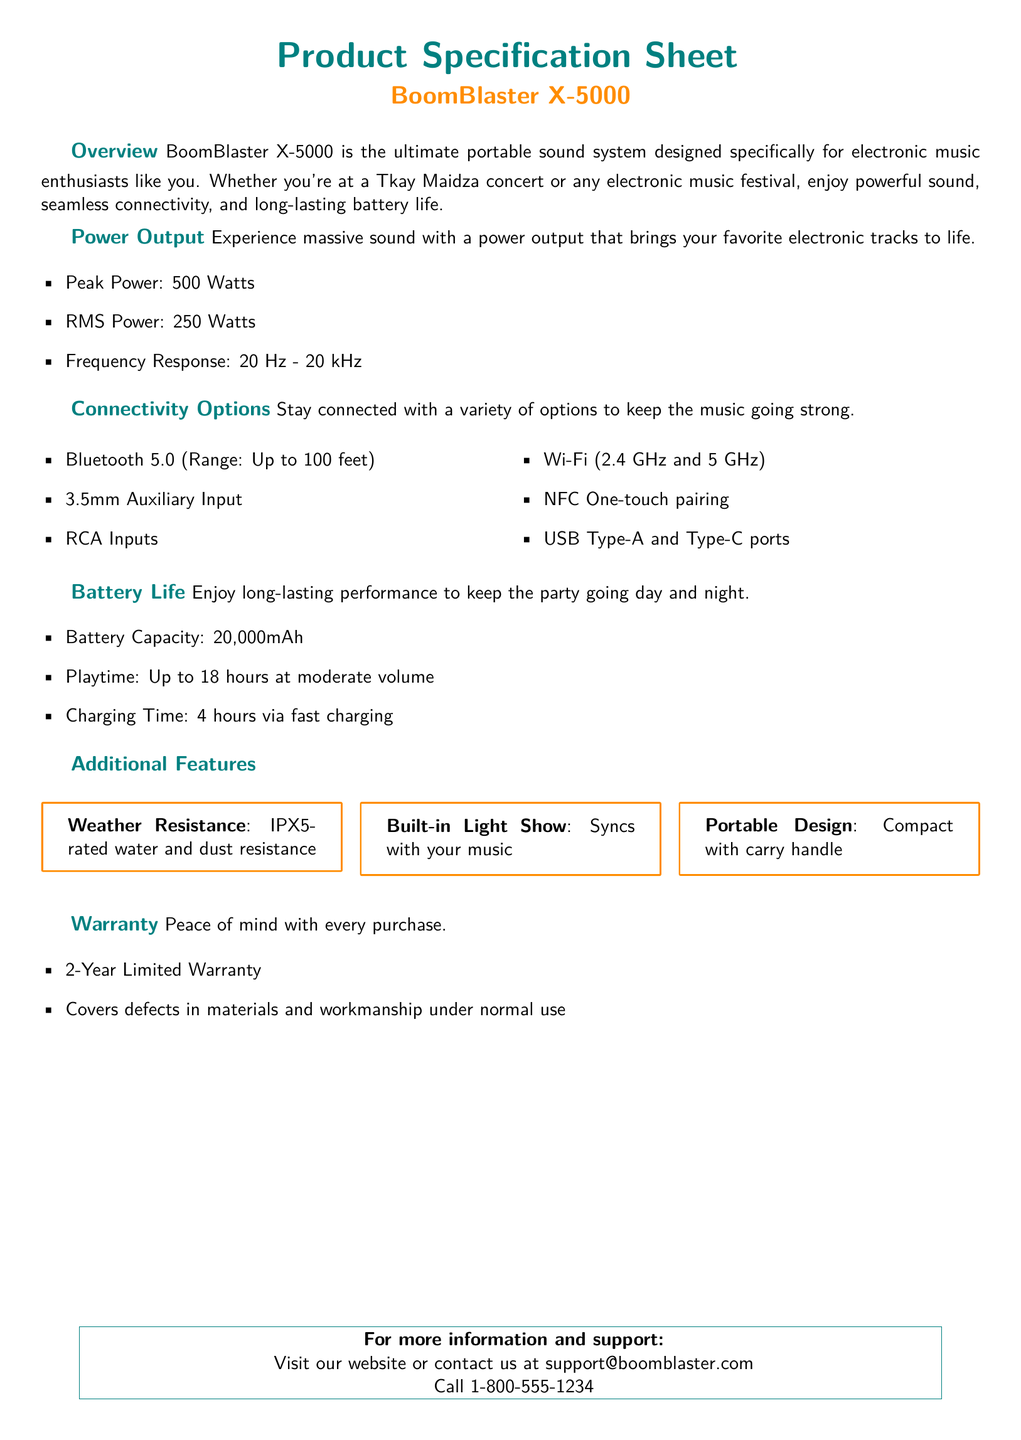What is the peak power output? The peak power output is specified in the document as 500 Watts.
Answer: 500 Watts What is the playtime at moderate volume? The document states that the playtime is up to 18 hours at moderate volume.
Answer: Up to 18 hours What connectivity option allows pairing with NFC? The document mentions NFC one-touch pairing as a connectivity option.
Answer: NFC One-touch pairing What is the battery capacity? The battery capacity listed in the document is 20,000mAh.
Answer: 20,000mAh What is the warranty period for the BoomBlaster X-5000? The document specifies a 2-Year Limited Warranty for the product.
Answer: 2-Year Limited Warranty How does the built-in light show function? The document explains that the built-in light show syncs with your music.
Answer: Syncs with your music What is the frequency response range? The frequency response range is mentioned as 20 Hz - 20 kHz in the document.
Answer: 20 Hz - 20 kHz What is the charging time via fast charging? The charging time listed in the document is 4 hours via fast charging.
Answer: 4 hours What feature provides weather resistance? The document states that the product has IPX5-rated water and dust resistance for weather resistance.
Answer: IPX5-rated water and dust resistance 